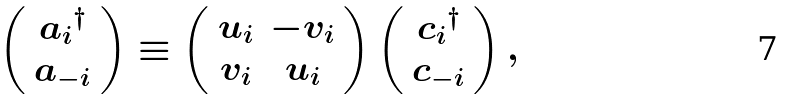<formula> <loc_0><loc_0><loc_500><loc_500>\left ( \begin{array} { c } { a _ { i } } ^ { \dagger } \\ { a _ { - i } } \end{array} \right ) \equiv \left ( \begin{array} { c c } u _ { i } & - v _ { i } \\ v _ { i } & u _ { i } \end{array} \right ) \left ( \begin{array} { c } { c _ { i } } ^ { \dagger } \\ { c _ { - i } } \end{array} \right ) ,</formula> 